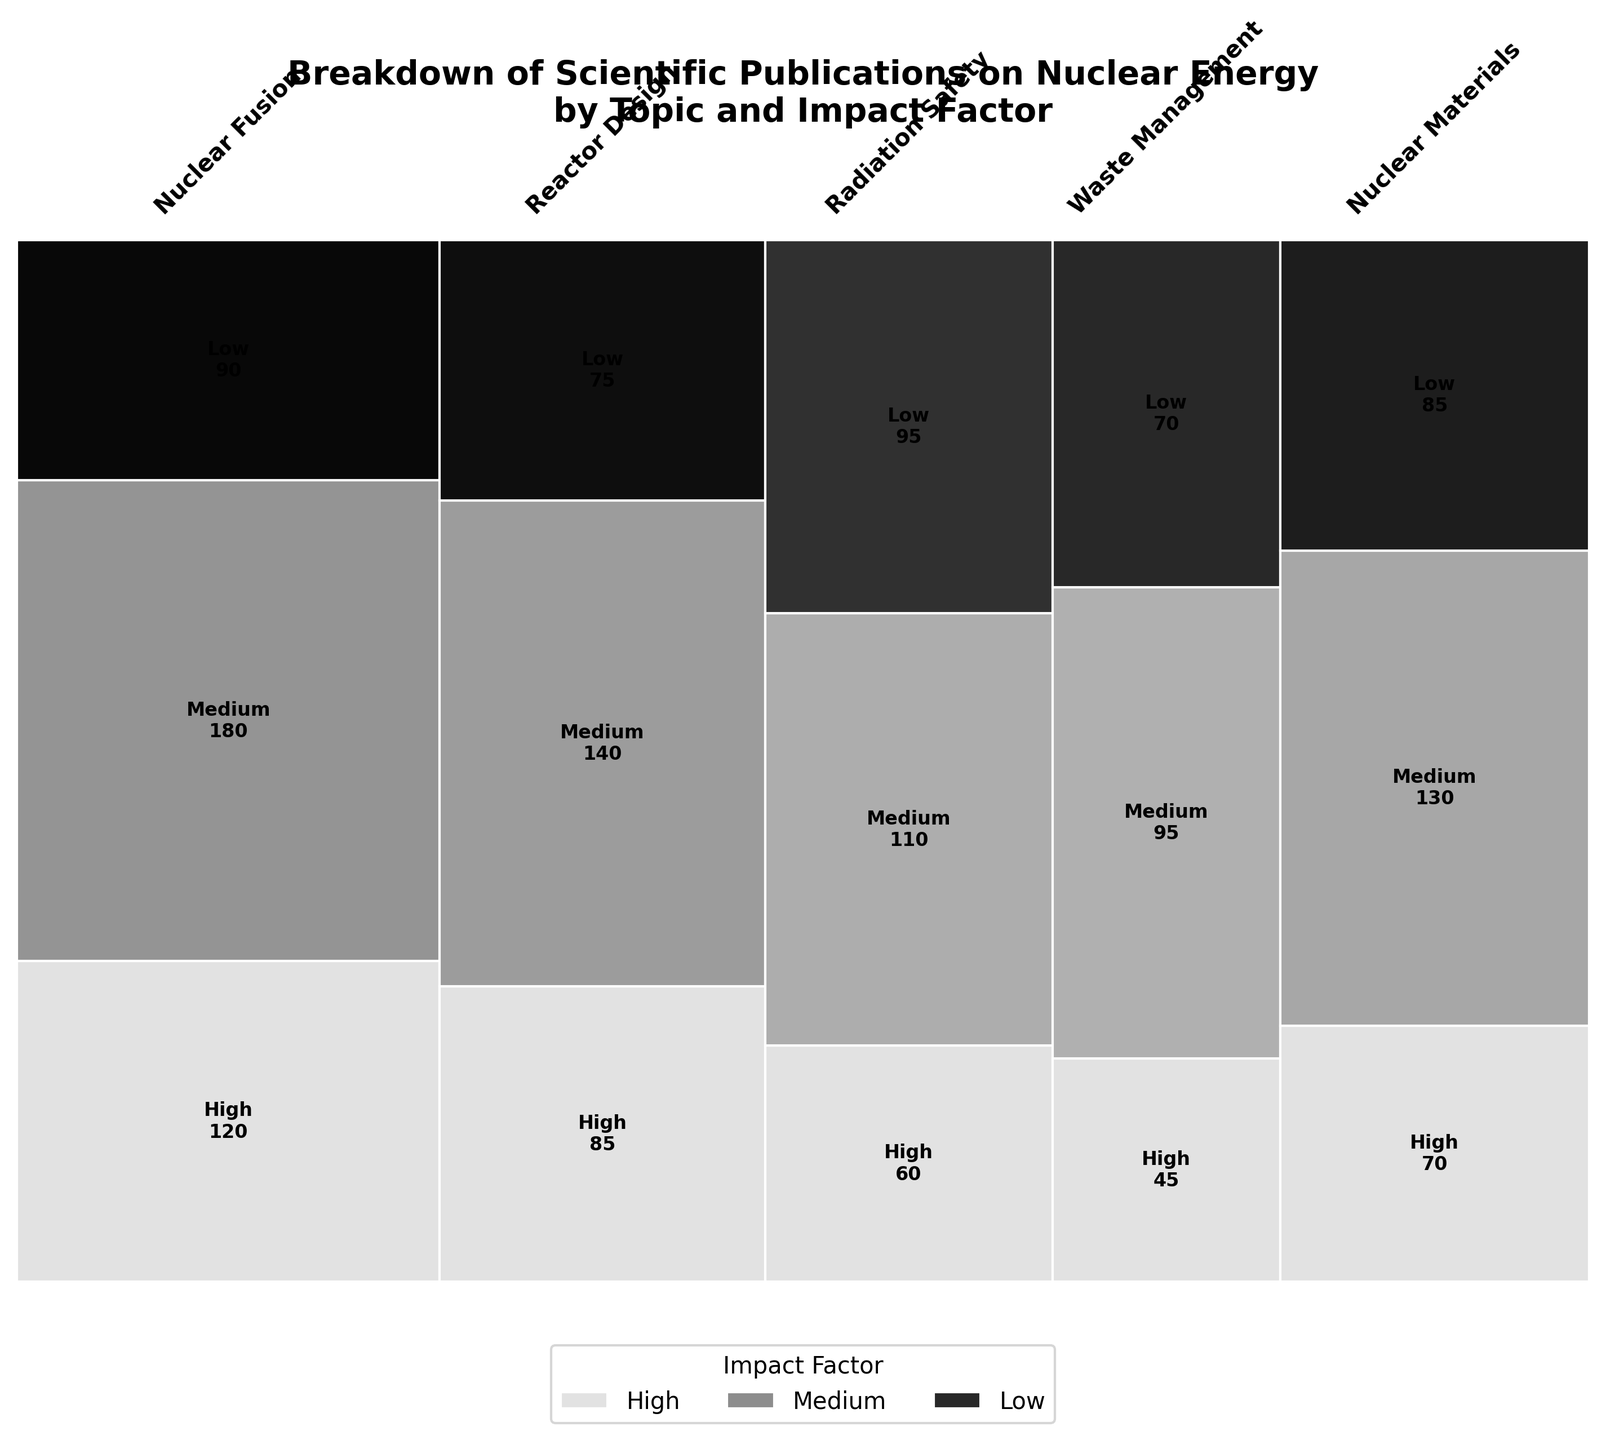How many topics are represented in the figure? To find the number of topics, look at the number of unique labels along the x-axis. Each label represents a different topic.
Answer: 5 Which topic has the highest total number of publications? To determine the topic with the highest total number of publications, compare the widths of the segments corresponding to each topic. The widest segment represents the topic with the highest number of publications.
Answer: Nuclear Fusion What is the total number of publications for Radiation Safety with a high impact factor? Identify the segment for Radiation Safety and look for the section labeled "High". Check the numerical value inside this section.
Answer: 60 Which impact factor category has the most publications across all topics? Add up the number of publications for each impact factor category (High, Medium, Low) across all topics. The category with the highest sum has the most publications.
Answer: Medium By how much do the publications for Reactor Design with a medium impact factor exceed those with a low impact factor? Find the number of publications for Reactor Design in both the medium and low impact factor sections. Subtract the number of low impact factor publications from the number of medium impact factor publications.
Answer: 65 Does Waste Management have more low impact factor publications compared to high impact factor publications? Compare the size of the segments in the Waste Management row labeled "Low" and "High". The numbers inside the segments give the number of publications.
Answer: Yes Which topic has the smallest proportion of high impact factor publications? Compare the sections labeled "High" for each topic and see which section occupies the smallest vertical space relative to its respective topic segment.
Answer: Waste Management For Nuclear Materials, calculate the combined total of publications with medium and high impact factors. Find the number of publications for Nuclear Materials with both medium and high impact factors, then add these two values together.
Answer: 200 Rank the topics from highest to lowest based on the number of low impact factor publications. Look at the sections labeled "Low" in each topic and compare their labels to rank them accordingly.
Answer: Nuclear Fusion, Radiation Safety, Nuclear Materials, Reactor Design, Waste Management Are there any topics where the total number of publications for medium impact factor is less than 100? Check the numbers in the segments labeled "Medium" for each topic to see if any are less than 100.
Answer: No 